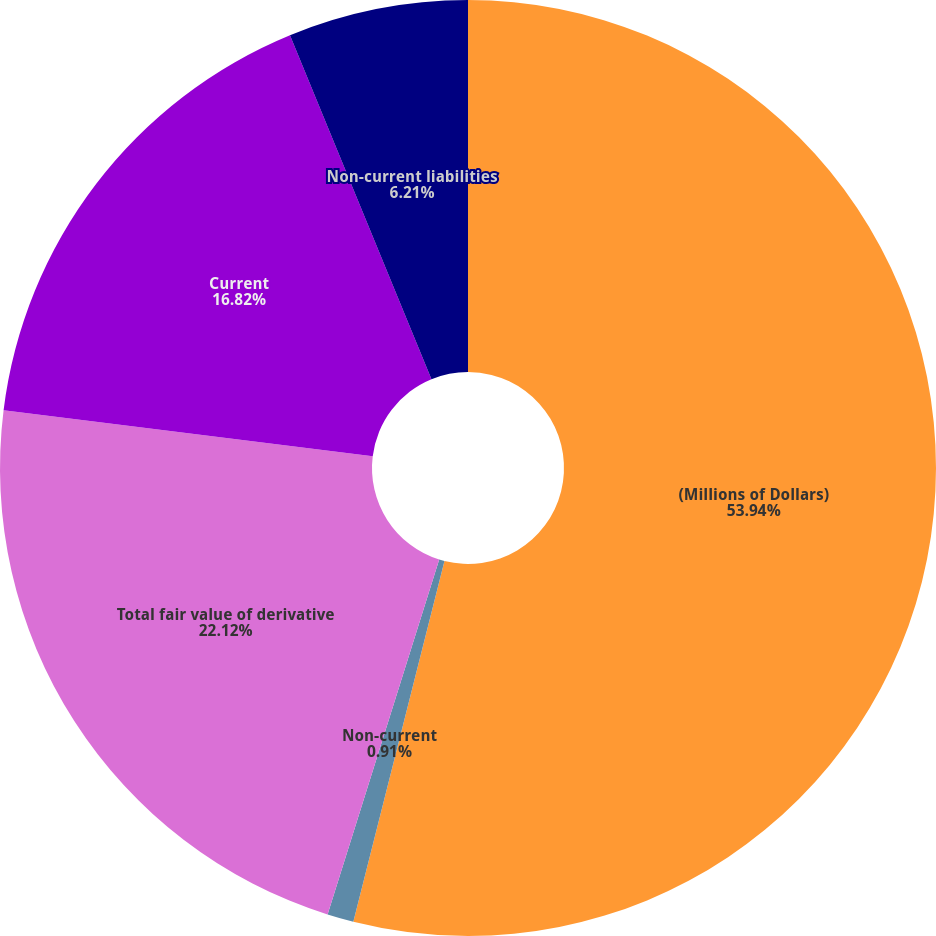<chart> <loc_0><loc_0><loc_500><loc_500><pie_chart><fcel>(Millions of Dollars)<fcel>Non-current<fcel>Total fair value of derivative<fcel>Current<fcel>Non-current liabilities<nl><fcel>53.94%<fcel>0.91%<fcel>22.12%<fcel>16.82%<fcel>6.21%<nl></chart> 